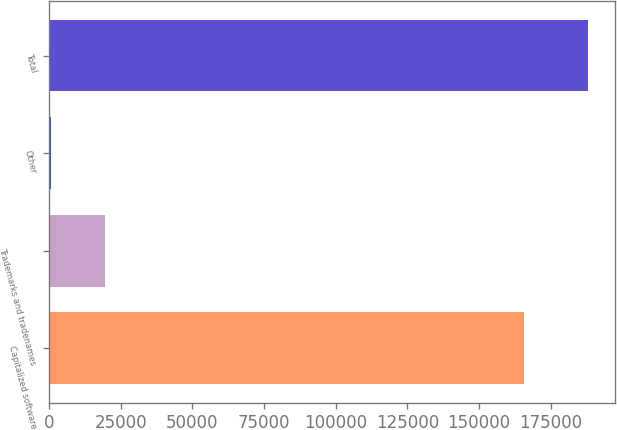Convert chart. <chart><loc_0><loc_0><loc_500><loc_500><bar_chart><fcel>Capitalized software<fcel>Trademarks and tradenames<fcel>Other<fcel>Total<nl><fcel>165565<fcel>19420.2<fcel>690<fcel>187992<nl></chart> 